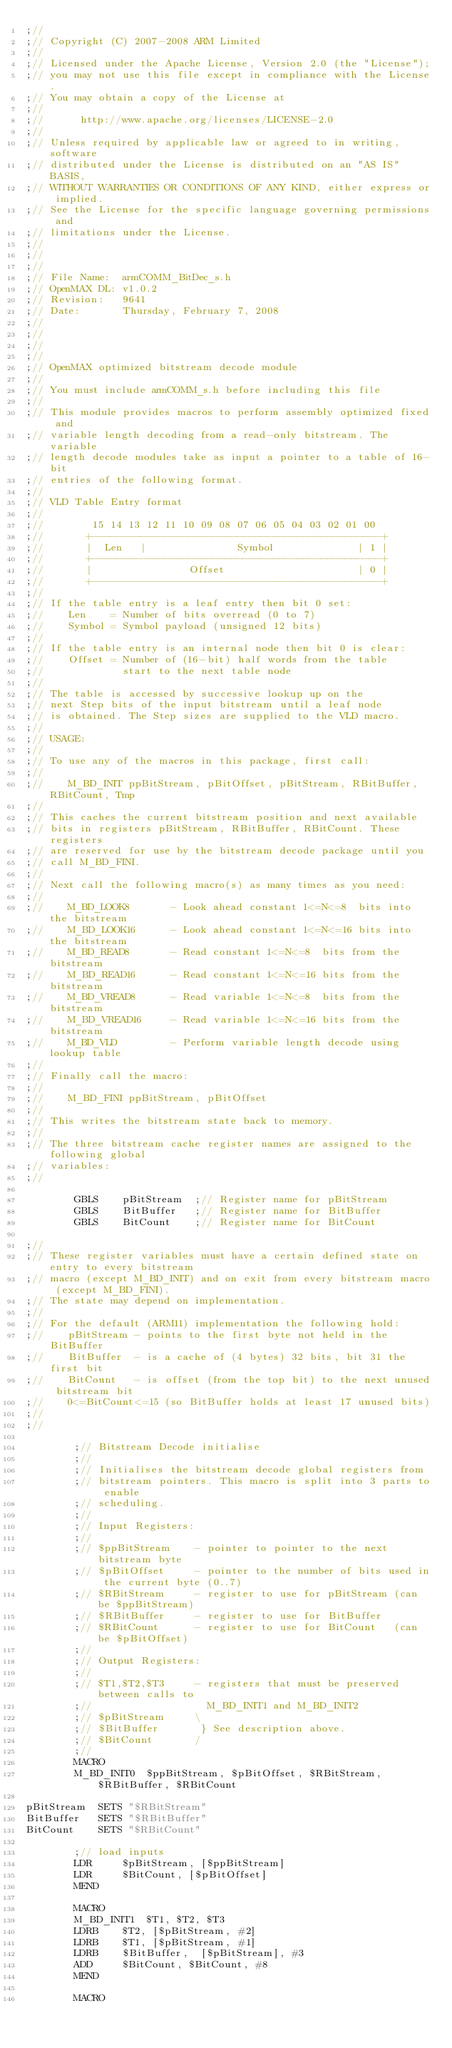Convert code to text. <code><loc_0><loc_0><loc_500><loc_500><_C_>;//
;// Copyright (C) 2007-2008 ARM Limited
;//
;// Licensed under the Apache License, Version 2.0 (the "License");
;// you may not use this file except in compliance with the License.
;// You may obtain a copy of the License at
;//
;//      http://www.apache.org/licenses/LICENSE-2.0
;//
;// Unless required by applicable law or agreed to in writing, software
;// distributed under the License is distributed on an "AS IS" BASIS,
;// WITHOUT WARRANTIES OR CONDITIONS OF ANY KIND, either express or implied.
;// See the License for the specific language governing permissions and
;// limitations under the License.
;//
;//
;// 
;// File Name:  armCOMM_BitDec_s.h
;// OpenMAX DL: v1.0.2
;// Revision:   9641
;// Date:       Thursday, February 7, 2008
;// 
;// 
;// 
;// 
;// OpenMAX optimized bitstream decode module
;//
;// You must include armCOMM_s.h before including this file
;//
;// This module provides macros to perform assembly optimized fixed and
;// variable length decoding from a read-only bitstream. The variable
;// length decode modules take as input a pointer to a table of 16-bit
;// entries of the following format.
;//
;// VLD Table Entry format
;//
;//        15 14 13 12 11 10 09 08 07 06 05 04 03 02 01 00
;//       +------------------------------------------------+
;//       |  Len   |               Symbol              | 1 |
;//       +------------------------------------------------+
;//       |                Offset                      | 0 |
;//       +------------------------------------------------+
;//
;// If the table entry is a leaf entry then bit 0 set:
;//    Len    = Number of bits overread (0 to 7)
;//    Symbol = Symbol payload (unsigned 12 bits)
;//
;// If the table entry is an internal node then bit 0 is clear:
;//    Offset = Number of (16-bit) half words from the table
;//             start to the next table node
;//
;// The table is accessed by successive lookup up on the
;// next Step bits of the input bitstream until a leaf node
;// is obtained. The Step sizes are supplied to the VLD macro.
;//
;// USAGE:
;//
;// To use any of the macros in this package, first call:
;//
;//    M_BD_INIT ppBitStream, pBitOffset, pBitStream, RBitBuffer, RBitCount, Tmp
;//
;// This caches the current bitstream position and next available
;// bits in registers pBitStream, RBitBuffer, RBitCount. These registers
;// are reserved for use by the bitstream decode package until you
;// call M_BD_FINI.
;//
;// Next call the following macro(s) as many times as you need:
;//
;//    M_BD_LOOK8       - Look ahead constant 1<=N<=8  bits into the bitstream
;//    M_BD_LOOK16      - Look ahead constant 1<=N<=16 bits into the bitstream
;//    M_BD_READ8       - Read constant 1<=N<=8  bits from the bitstream
;//    M_BD_READ16      - Read constant 1<=N<=16 bits from the bitstream
;//    M_BD_VREAD8      - Read variable 1<=N<=8  bits from the bitstream
;//    M_BD_VREAD16     - Read variable 1<=N<=16 bits from the bitstream
;//    M_BD_VLD         - Perform variable length decode using lookup table
;//
;// Finally call the macro:
;//
;//    M_BD_FINI ppBitStream, pBitOffset
;//
;// This writes the bitstream state back to memory.
;//
;// The three bitstream cache register names are assigned to the following global
;// variables:
;//

        GBLS    pBitStream  ;// Register name for pBitStream
        GBLS    BitBuffer   ;// Register name for BitBuffer
        GBLS    BitCount    ;// Register name for BitCount
   
;//        
;// These register variables must have a certain defined state on entry to every bitstream
;// macro (except M_BD_INIT) and on exit from every bitstream macro (except M_BD_FINI).
;// The state may depend on implementation.
;//
;// For the default (ARM11) implementation the following hold:
;//    pBitStream - points to the first byte not held in the BitBuffer
;//    BitBuffer  - is a cache of (4 bytes) 32 bits, bit 31 the first bit
;//    BitCount   - is offset (from the top bit) to the next unused bitstream bit
;//    0<=BitCount<=15 (so BitBuffer holds at least 17 unused bits)
;//
;//

        ;// Bitstream Decode initialise
        ;//
        ;// Initialises the bitstream decode global registers from
        ;// bitstream pointers. This macro is split into 3 parts to enable
        ;// scheduling.
        ;//
        ;// Input Registers:
        ;//
        ;// $ppBitStream    - pointer to pointer to the next bitstream byte
        ;// $pBitOffset     - pointer to the number of bits used in the current byte (0..7)
        ;// $RBitStream     - register to use for pBitStream (can be $ppBitStream)
        ;// $RBitBuffer     - register to use for BitBuffer
        ;// $RBitCount      - register to use for BitCount   (can be $pBitOffset)
        ;//
        ;// Output Registers:
        ;//
        ;// $T1,$T2,$T3     - registers that must be preserved between calls to
        ;//                   M_BD_INIT1 and M_BD_INIT2
        ;// $pBitStream     \ 
        ;// $BitBuffer       } See description above.
        ;// $BitCount       / 
        ;//
        MACRO
        M_BD_INIT0  $ppBitStream, $pBitOffset, $RBitStream, $RBitBuffer, $RBitCount

pBitStream  SETS "$RBitStream"
BitBuffer   SETS "$RBitBuffer"
BitCount    SETS "$RBitCount"        
        
        ;// load inputs
        LDR     $pBitStream, [$ppBitStream]
        LDR     $BitCount, [$pBitOffset]
        MEND
        
        MACRO
        M_BD_INIT1  $T1, $T2, $T3
        LDRB    $T2, [$pBitStream, #2]
        LDRB    $T1, [$pBitStream, #1]
        LDRB    $BitBuffer,  [$pBitStream], #3
        ADD     $BitCount, $BitCount, #8
        MEND
        
        MACRO</code> 